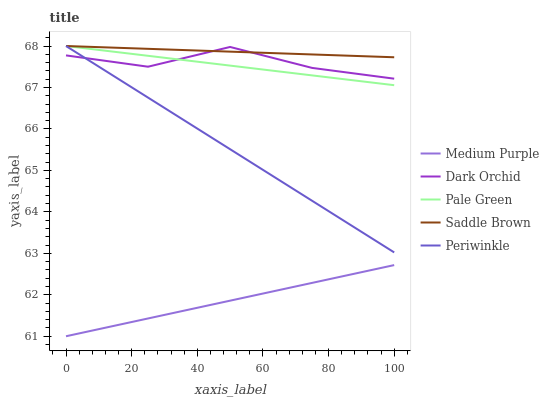Does Pale Green have the minimum area under the curve?
Answer yes or no. No. Does Pale Green have the maximum area under the curve?
Answer yes or no. No. Is Pale Green the smoothest?
Answer yes or no. No. Is Pale Green the roughest?
Answer yes or no. No. Does Pale Green have the lowest value?
Answer yes or no. No. Does Dark Orchid have the highest value?
Answer yes or no. No. Is Medium Purple less than Periwinkle?
Answer yes or no. Yes. Is Periwinkle greater than Medium Purple?
Answer yes or no. Yes. Does Medium Purple intersect Periwinkle?
Answer yes or no. No. 